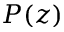Convert formula to latex. <formula><loc_0><loc_0><loc_500><loc_500>P ( z )</formula> 